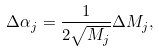<formula> <loc_0><loc_0><loc_500><loc_500>\Delta \alpha _ { j } = \frac { 1 } { 2 \sqrt { M _ { j } } } \Delta M _ { j } ,</formula> 